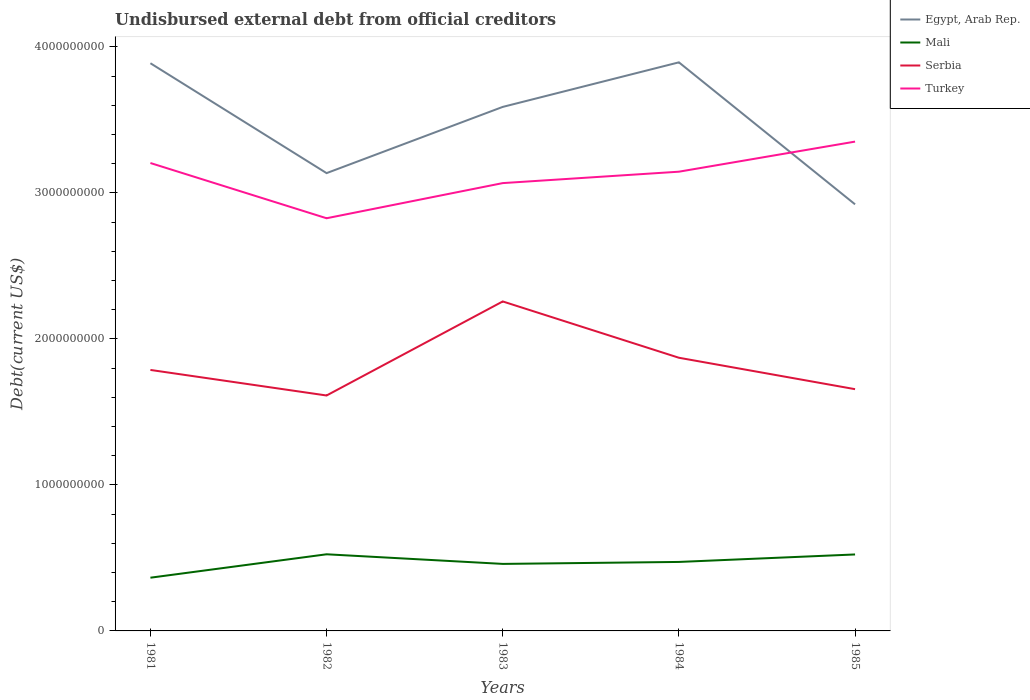How many different coloured lines are there?
Keep it short and to the point. 4. Does the line corresponding to Mali intersect with the line corresponding to Serbia?
Your answer should be very brief. No. Across all years, what is the maximum total debt in Mali?
Make the answer very short. 3.65e+08. What is the total total debt in Turkey in the graph?
Your answer should be compact. -1.47e+08. What is the difference between the highest and the second highest total debt in Turkey?
Offer a terse response. 5.25e+08. Is the total debt in Turkey strictly greater than the total debt in Serbia over the years?
Offer a very short reply. No. How many lines are there?
Offer a terse response. 4. What is the difference between two consecutive major ticks on the Y-axis?
Give a very brief answer. 1.00e+09. Are the values on the major ticks of Y-axis written in scientific E-notation?
Your answer should be compact. No. Does the graph contain any zero values?
Offer a very short reply. No. Does the graph contain grids?
Make the answer very short. No. Where does the legend appear in the graph?
Make the answer very short. Top right. How many legend labels are there?
Your answer should be very brief. 4. How are the legend labels stacked?
Give a very brief answer. Vertical. What is the title of the graph?
Your answer should be very brief. Undisbursed external debt from official creditors. Does "High income: OECD" appear as one of the legend labels in the graph?
Offer a terse response. No. What is the label or title of the X-axis?
Offer a very short reply. Years. What is the label or title of the Y-axis?
Keep it short and to the point. Debt(current US$). What is the Debt(current US$) of Egypt, Arab Rep. in 1981?
Offer a terse response. 3.89e+09. What is the Debt(current US$) in Mali in 1981?
Keep it short and to the point. 3.65e+08. What is the Debt(current US$) of Serbia in 1981?
Give a very brief answer. 1.79e+09. What is the Debt(current US$) of Turkey in 1981?
Provide a short and direct response. 3.20e+09. What is the Debt(current US$) in Egypt, Arab Rep. in 1982?
Provide a short and direct response. 3.14e+09. What is the Debt(current US$) of Mali in 1982?
Offer a very short reply. 5.25e+08. What is the Debt(current US$) of Serbia in 1982?
Make the answer very short. 1.61e+09. What is the Debt(current US$) in Turkey in 1982?
Ensure brevity in your answer.  2.83e+09. What is the Debt(current US$) in Egypt, Arab Rep. in 1983?
Offer a very short reply. 3.59e+09. What is the Debt(current US$) in Mali in 1983?
Give a very brief answer. 4.59e+08. What is the Debt(current US$) in Serbia in 1983?
Provide a short and direct response. 2.26e+09. What is the Debt(current US$) in Turkey in 1983?
Your answer should be compact. 3.07e+09. What is the Debt(current US$) in Egypt, Arab Rep. in 1984?
Provide a short and direct response. 3.89e+09. What is the Debt(current US$) in Mali in 1984?
Offer a very short reply. 4.72e+08. What is the Debt(current US$) in Serbia in 1984?
Provide a short and direct response. 1.87e+09. What is the Debt(current US$) of Turkey in 1984?
Your answer should be compact. 3.15e+09. What is the Debt(current US$) of Egypt, Arab Rep. in 1985?
Your answer should be very brief. 2.92e+09. What is the Debt(current US$) in Mali in 1985?
Provide a succinct answer. 5.24e+08. What is the Debt(current US$) in Serbia in 1985?
Make the answer very short. 1.66e+09. What is the Debt(current US$) in Turkey in 1985?
Your answer should be compact. 3.35e+09. Across all years, what is the maximum Debt(current US$) in Egypt, Arab Rep.?
Your response must be concise. 3.89e+09. Across all years, what is the maximum Debt(current US$) of Mali?
Offer a very short reply. 5.25e+08. Across all years, what is the maximum Debt(current US$) in Serbia?
Your answer should be compact. 2.26e+09. Across all years, what is the maximum Debt(current US$) in Turkey?
Give a very brief answer. 3.35e+09. Across all years, what is the minimum Debt(current US$) in Egypt, Arab Rep.?
Provide a succinct answer. 2.92e+09. Across all years, what is the minimum Debt(current US$) in Mali?
Make the answer very short. 3.65e+08. Across all years, what is the minimum Debt(current US$) of Serbia?
Ensure brevity in your answer.  1.61e+09. Across all years, what is the minimum Debt(current US$) in Turkey?
Make the answer very short. 2.83e+09. What is the total Debt(current US$) in Egypt, Arab Rep. in the graph?
Your answer should be very brief. 1.74e+1. What is the total Debt(current US$) of Mali in the graph?
Your response must be concise. 2.34e+09. What is the total Debt(current US$) of Serbia in the graph?
Your response must be concise. 9.18e+09. What is the total Debt(current US$) of Turkey in the graph?
Provide a short and direct response. 1.56e+1. What is the difference between the Debt(current US$) of Egypt, Arab Rep. in 1981 and that in 1982?
Your answer should be compact. 7.53e+08. What is the difference between the Debt(current US$) in Mali in 1981 and that in 1982?
Offer a terse response. -1.60e+08. What is the difference between the Debt(current US$) of Serbia in 1981 and that in 1982?
Keep it short and to the point. 1.75e+08. What is the difference between the Debt(current US$) in Turkey in 1981 and that in 1982?
Provide a short and direct response. 3.78e+08. What is the difference between the Debt(current US$) in Egypt, Arab Rep. in 1981 and that in 1983?
Give a very brief answer. 2.99e+08. What is the difference between the Debt(current US$) of Mali in 1981 and that in 1983?
Make the answer very short. -9.45e+07. What is the difference between the Debt(current US$) in Serbia in 1981 and that in 1983?
Keep it short and to the point. -4.69e+08. What is the difference between the Debt(current US$) of Turkey in 1981 and that in 1983?
Provide a succinct answer. 1.38e+08. What is the difference between the Debt(current US$) of Egypt, Arab Rep. in 1981 and that in 1984?
Your answer should be compact. -6.11e+06. What is the difference between the Debt(current US$) of Mali in 1981 and that in 1984?
Provide a short and direct response. -1.08e+08. What is the difference between the Debt(current US$) of Serbia in 1981 and that in 1984?
Make the answer very short. -8.35e+07. What is the difference between the Debt(current US$) in Turkey in 1981 and that in 1984?
Offer a terse response. 5.95e+07. What is the difference between the Debt(current US$) in Egypt, Arab Rep. in 1981 and that in 1985?
Your answer should be very brief. 9.66e+08. What is the difference between the Debt(current US$) of Mali in 1981 and that in 1985?
Your answer should be very brief. -1.59e+08. What is the difference between the Debt(current US$) in Serbia in 1981 and that in 1985?
Provide a succinct answer. 1.32e+08. What is the difference between the Debt(current US$) of Turkey in 1981 and that in 1985?
Provide a succinct answer. -1.47e+08. What is the difference between the Debt(current US$) of Egypt, Arab Rep. in 1982 and that in 1983?
Provide a short and direct response. -4.54e+08. What is the difference between the Debt(current US$) of Mali in 1982 and that in 1983?
Provide a short and direct response. 6.59e+07. What is the difference between the Debt(current US$) in Serbia in 1982 and that in 1983?
Your answer should be compact. -6.44e+08. What is the difference between the Debt(current US$) of Turkey in 1982 and that in 1983?
Keep it short and to the point. -2.41e+08. What is the difference between the Debt(current US$) of Egypt, Arab Rep. in 1982 and that in 1984?
Your response must be concise. -7.59e+08. What is the difference between the Debt(current US$) in Mali in 1982 and that in 1984?
Make the answer very short. 5.24e+07. What is the difference between the Debt(current US$) in Serbia in 1982 and that in 1984?
Provide a succinct answer. -2.59e+08. What is the difference between the Debt(current US$) of Turkey in 1982 and that in 1984?
Make the answer very short. -3.19e+08. What is the difference between the Debt(current US$) in Egypt, Arab Rep. in 1982 and that in 1985?
Offer a very short reply. 2.14e+08. What is the difference between the Debt(current US$) in Mali in 1982 and that in 1985?
Make the answer very short. 1.17e+06. What is the difference between the Debt(current US$) of Serbia in 1982 and that in 1985?
Ensure brevity in your answer.  -4.33e+07. What is the difference between the Debt(current US$) of Turkey in 1982 and that in 1985?
Give a very brief answer. -5.25e+08. What is the difference between the Debt(current US$) in Egypt, Arab Rep. in 1983 and that in 1984?
Your answer should be very brief. -3.05e+08. What is the difference between the Debt(current US$) of Mali in 1983 and that in 1984?
Your answer should be very brief. -1.34e+07. What is the difference between the Debt(current US$) of Serbia in 1983 and that in 1984?
Make the answer very short. 3.86e+08. What is the difference between the Debt(current US$) in Turkey in 1983 and that in 1984?
Offer a very short reply. -7.81e+07. What is the difference between the Debt(current US$) of Egypt, Arab Rep. in 1983 and that in 1985?
Offer a very short reply. 6.67e+08. What is the difference between the Debt(current US$) in Mali in 1983 and that in 1985?
Your response must be concise. -6.47e+07. What is the difference between the Debt(current US$) in Serbia in 1983 and that in 1985?
Provide a short and direct response. 6.01e+08. What is the difference between the Debt(current US$) of Turkey in 1983 and that in 1985?
Give a very brief answer. -2.84e+08. What is the difference between the Debt(current US$) of Egypt, Arab Rep. in 1984 and that in 1985?
Provide a short and direct response. 9.72e+08. What is the difference between the Debt(current US$) in Mali in 1984 and that in 1985?
Offer a very short reply. -5.13e+07. What is the difference between the Debt(current US$) of Serbia in 1984 and that in 1985?
Offer a terse response. 2.15e+08. What is the difference between the Debt(current US$) of Turkey in 1984 and that in 1985?
Make the answer very short. -2.06e+08. What is the difference between the Debt(current US$) of Egypt, Arab Rep. in 1981 and the Debt(current US$) of Mali in 1982?
Ensure brevity in your answer.  3.36e+09. What is the difference between the Debt(current US$) in Egypt, Arab Rep. in 1981 and the Debt(current US$) in Serbia in 1982?
Make the answer very short. 2.28e+09. What is the difference between the Debt(current US$) in Egypt, Arab Rep. in 1981 and the Debt(current US$) in Turkey in 1982?
Your answer should be very brief. 1.06e+09. What is the difference between the Debt(current US$) of Mali in 1981 and the Debt(current US$) of Serbia in 1982?
Your answer should be very brief. -1.25e+09. What is the difference between the Debt(current US$) of Mali in 1981 and the Debt(current US$) of Turkey in 1982?
Your answer should be very brief. -2.46e+09. What is the difference between the Debt(current US$) of Serbia in 1981 and the Debt(current US$) of Turkey in 1982?
Give a very brief answer. -1.04e+09. What is the difference between the Debt(current US$) in Egypt, Arab Rep. in 1981 and the Debt(current US$) in Mali in 1983?
Your answer should be compact. 3.43e+09. What is the difference between the Debt(current US$) of Egypt, Arab Rep. in 1981 and the Debt(current US$) of Serbia in 1983?
Offer a very short reply. 1.63e+09. What is the difference between the Debt(current US$) in Egypt, Arab Rep. in 1981 and the Debt(current US$) in Turkey in 1983?
Make the answer very short. 8.21e+08. What is the difference between the Debt(current US$) in Mali in 1981 and the Debt(current US$) in Serbia in 1983?
Provide a succinct answer. -1.89e+09. What is the difference between the Debt(current US$) of Mali in 1981 and the Debt(current US$) of Turkey in 1983?
Provide a short and direct response. -2.70e+09. What is the difference between the Debt(current US$) in Serbia in 1981 and the Debt(current US$) in Turkey in 1983?
Your answer should be very brief. -1.28e+09. What is the difference between the Debt(current US$) of Egypt, Arab Rep. in 1981 and the Debt(current US$) of Mali in 1984?
Offer a very short reply. 3.42e+09. What is the difference between the Debt(current US$) of Egypt, Arab Rep. in 1981 and the Debt(current US$) of Serbia in 1984?
Provide a succinct answer. 2.02e+09. What is the difference between the Debt(current US$) in Egypt, Arab Rep. in 1981 and the Debt(current US$) in Turkey in 1984?
Your response must be concise. 7.43e+08. What is the difference between the Debt(current US$) in Mali in 1981 and the Debt(current US$) in Serbia in 1984?
Give a very brief answer. -1.51e+09. What is the difference between the Debt(current US$) of Mali in 1981 and the Debt(current US$) of Turkey in 1984?
Provide a short and direct response. -2.78e+09. What is the difference between the Debt(current US$) of Serbia in 1981 and the Debt(current US$) of Turkey in 1984?
Provide a short and direct response. -1.36e+09. What is the difference between the Debt(current US$) in Egypt, Arab Rep. in 1981 and the Debt(current US$) in Mali in 1985?
Your answer should be very brief. 3.36e+09. What is the difference between the Debt(current US$) of Egypt, Arab Rep. in 1981 and the Debt(current US$) of Serbia in 1985?
Your response must be concise. 2.23e+09. What is the difference between the Debt(current US$) in Egypt, Arab Rep. in 1981 and the Debt(current US$) in Turkey in 1985?
Your answer should be compact. 5.37e+08. What is the difference between the Debt(current US$) of Mali in 1981 and the Debt(current US$) of Serbia in 1985?
Your answer should be very brief. -1.29e+09. What is the difference between the Debt(current US$) of Mali in 1981 and the Debt(current US$) of Turkey in 1985?
Provide a short and direct response. -2.99e+09. What is the difference between the Debt(current US$) of Serbia in 1981 and the Debt(current US$) of Turkey in 1985?
Provide a short and direct response. -1.56e+09. What is the difference between the Debt(current US$) in Egypt, Arab Rep. in 1982 and the Debt(current US$) in Mali in 1983?
Offer a very short reply. 2.68e+09. What is the difference between the Debt(current US$) of Egypt, Arab Rep. in 1982 and the Debt(current US$) of Serbia in 1983?
Ensure brevity in your answer.  8.79e+08. What is the difference between the Debt(current US$) in Egypt, Arab Rep. in 1982 and the Debt(current US$) in Turkey in 1983?
Your response must be concise. 6.83e+07. What is the difference between the Debt(current US$) of Mali in 1982 and the Debt(current US$) of Serbia in 1983?
Your answer should be very brief. -1.73e+09. What is the difference between the Debt(current US$) in Mali in 1982 and the Debt(current US$) in Turkey in 1983?
Offer a very short reply. -2.54e+09. What is the difference between the Debt(current US$) of Serbia in 1982 and the Debt(current US$) of Turkey in 1983?
Make the answer very short. -1.45e+09. What is the difference between the Debt(current US$) of Egypt, Arab Rep. in 1982 and the Debt(current US$) of Mali in 1984?
Make the answer very short. 2.66e+09. What is the difference between the Debt(current US$) in Egypt, Arab Rep. in 1982 and the Debt(current US$) in Serbia in 1984?
Make the answer very short. 1.26e+09. What is the difference between the Debt(current US$) in Egypt, Arab Rep. in 1982 and the Debt(current US$) in Turkey in 1984?
Your response must be concise. -9.78e+06. What is the difference between the Debt(current US$) of Mali in 1982 and the Debt(current US$) of Serbia in 1984?
Provide a short and direct response. -1.35e+09. What is the difference between the Debt(current US$) in Mali in 1982 and the Debt(current US$) in Turkey in 1984?
Offer a terse response. -2.62e+09. What is the difference between the Debt(current US$) in Serbia in 1982 and the Debt(current US$) in Turkey in 1984?
Offer a very short reply. -1.53e+09. What is the difference between the Debt(current US$) in Egypt, Arab Rep. in 1982 and the Debt(current US$) in Mali in 1985?
Your answer should be compact. 2.61e+09. What is the difference between the Debt(current US$) in Egypt, Arab Rep. in 1982 and the Debt(current US$) in Serbia in 1985?
Offer a very short reply. 1.48e+09. What is the difference between the Debt(current US$) in Egypt, Arab Rep. in 1982 and the Debt(current US$) in Turkey in 1985?
Give a very brief answer. -2.16e+08. What is the difference between the Debt(current US$) in Mali in 1982 and the Debt(current US$) in Serbia in 1985?
Give a very brief answer. -1.13e+09. What is the difference between the Debt(current US$) in Mali in 1982 and the Debt(current US$) in Turkey in 1985?
Your answer should be very brief. -2.83e+09. What is the difference between the Debt(current US$) in Serbia in 1982 and the Debt(current US$) in Turkey in 1985?
Keep it short and to the point. -1.74e+09. What is the difference between the Debt(current US$) of Egypt, Arab Rep. in 1983 and the Debt(current US$) of Mali in 1984?
Offer a very short reply. 3.12e+09. What is the difference between the Debt(current US$) in Egypt, Arab Rep. in 1983 and the Debt(current US$) in Serbia in 1984?
Provide a succinct answer. 1.72e+09. What is the difference between the Debt(current US$) in Egypt, Arab Rep. in 1983 and the Debt(current US$) in Turkey in 1984?
Your answer should be very brief. 4.44e+08. What is the difference between the Debt(current US$) of Mali in 1983 and the Debt(current US$) of Serbia in 1984?
Provide a short and direct response. -1.41e+09. What is the difference between the Debt(current US$) in Mali in 1983 and the Debt(current US$) in Turkey in 1984?
Give a very brief answer. -2.69e+09. What is the difference between the Debt(current US$) of Serbia in 1983 and the Debt(current US$) of Turkey in 1984?
Make the answer very short. -8.89e+08. What is the difference between the Debt(current US$) in Egypt, Arab Rep. in 1983 and the Debt(current US$) in Mali in 1985?
Offer a very short reply. 3.07e+09. What is the difference between the Debt(current US$) in Egypt, Arab Rep. in 1983 and the Debt(current US$) in Serbia in 1985?
Your answer should be very brief. 1.93e+09. What is the difference between the Debt(current US$) of Egypt, Arab Rep. in 1983 and the Debt(current US$) of Turkey in 1985?
Make the answer very short. 2.38e+08. What is the difference between the Debt(current US$) of Mali in 1983 and the Debt(current US$) of Serbia in 1985?
Your answer should be very brief. -1.20e+09. What is the difference between the Debt(current US$) in Mali in 1983 and the Debt(current US$) in Turkey in 1985?
Your answer should be compact. -2.89e+09. What is the difference between the Debt(current US$) in Serbia in 1983 and the Debt(current US$) in Turkey in 1985?
Your answer should be very brief. -1.09e+09. What is the difference between the Debt(current US$) in Egypt, Arab Rep. in 1984 and the Debt(current US$) in Mali in 1985?
Make the answer very short. 3.37e+09. What is the difference between the Debt(current US$) of Egypt, Arab Rep. in 1984 and the Debt(current US$) of Serbia in 1985?
Offer a terse response. 2.24e+09. What is the difference between the Debt(current US$) in Egypt, Arab Rep. in 1984 and the Debt(current US$) in Turkey in 1985?
Offer a very short reply. 5.43e+08. What is the difference between the Debt(current US$) of Mali in 1984 and the Debt(current US$) of Serbia in 1985?
Your response must be concise. -1.18e+09. What is the difference between the Debt(current US$) of Mali in 1984 and the Debt(current US$) of Turkey in 1985?
Your response must be concise. -2.88e+09. What is the difference between the Debt(current US$) of Serbia in 1984 and the Debt(current US$) of Turkey in 1985?
Make the answer very short. -1.48e+09. What is the average Debt(current US$) in Egypt, Arab Rep. per year?
Make the answer very short. 3.49e+09. What is the average Debt(current US$) in Mali per year?
Your response must be concise. 4.69e+08. What is the average Debt(current US$) of Serbia per year?
Provide a short and direct response. 1.84e+09. What is the average Debt(current US$) in Turkey per year?
Give a very brief answer. 3.12e+09. In the year 1981, what is the difference between the Debt(current US$) of Egypt, Arab Rep. and Debt(current US$) of Mali?
Your answer should be compact. 3.52e+09. In the year 1981, what is the difference between the Debt(current US$) of Egypt, Arab Rep. and Debt(current US$) of Serbia?
Your answer should be very brief. 2.10e+09. In the year 1981, what is the difference between the Debt(current US$) in Egypt, Arab Rep. and Debt(current US$) in Turkey?
Offer a terse response. 6.83e+08. In the year 1981, what is the difference between the Debt(current US$) of Mali and Debt(current US$) of Serbia?
Your answer should be very brief. -1.42e+09. In the year 1981, what is the difference between the Debt(current US$) in Mali and Debt(current US$) in Turkey?
Provide a short and direct response. -2.84e+09. In the year 1981, what is the difference between the Debt(current US$) in Serbia and Debt(current US$) in Turkey?
Offer a terse response. -1.42e+09. In the year 1982, what is the difference between the Debt(current US$) of Egypt, Arab Rep. and Debt(current US$) of Mali?
Give a very brief answer. 2.61e+09. In the year 1982, what is the difference between the Debt(current US$) in Egypt, Arab Rep. and Debt(current US$) in Serbia?
Offer a terse response. 1.52e+09. In the year 1982, what is the difference between the Debt(current US$) of Egypt, Arab Rep. and Debt(current US$) of Turkey?
Offer a very short reply. 3.09e+08. In the year 1982, what is the difference between the Debt(current US$) in Mali and Debt(current US$) in Serbia?
Your answer should be compact. -1.09e+09. In the year 1982, what is the difference between the Debt(current US$) in Mali and Debt(current US$) in Turkey?
Make the answer very short. -2.30e+09. In the year 1982, what is the difference between the Debt(current US$) in Serbia and Debt(current US$) in Turkey?
Your answer should be compact. -1.21e+09. In the year 1983, what is the difference between the Debt(current US$) in Egypt, Arab Rep. and Debt(current US$) in Mali?
Ensure brevity in your answer.  3.13e+09. In the year 1983, what is the difference between the Debt(current US$) in Egypt, Arab Rep. and Debt(current US$) in Serbia?
Your response must be concise. 1.33e+09. In the year 1983, what is the difference between the Debt(current US$) in Egypt, Arab Rep. and Debt(current US$) in Turkey?
Keep it short and to the point. 5.22e+08. In the year 1983, what is the difference between the Debt(current US$) in Mali and Debt(current US$) in Serbia?
Your response must be concise. -1.80e+09. In the year 1983, what is the difference between the Debt(current US$) of Mali and Debt(current US$) of Turkey?
Provide a short and direct response. -2.61e+09. In the year 1983, what is the difference between the Debt(current US$) of Serbia and Debt(current US$) of Turkey?
Offer a very short reply. -8.10e+08. In the year 1984, what is the difference between the Debt(current US$) in Egypt, Arab Rep. and Debt(current US$) in Mali?
Keep it short and to the point. 3.42e+09. In the year 1984, what is the difference between the Debt(current US$) of Egypt, Arab Rep. and Debt(current US$) of Serbia?
Your answer should be very brief. 2.02e+09. In the year 1984, what is the difference between the Debt(current US$) of Egypt, Arab Rep. and Debt(current US$) of Turkey?
Keep it short and to the point. 7.49e+08. In the year 1984, what is the difference between the Debt(current US$) in Mali and Debt(current US$) in Serbia?
Make the answer very short. -1.40e+09. In the year 1984, what is the difference between the Debt(current US$) in Mali and Debt(current US$) in Turkey?
Keep it short and to the point. -2.67e+09. In the year 1984, what is the difference between the Debt(current US$) in Serbia and Debt(current US$) in Turkey?
Your response must be concise. -1.27e+09. In the year 1985, what is the difference between the Debt(current US$) of Egypt, Arab Rep. and Debt(current US$) of Mali?
Offer a terse response. 2.40e+09. In the year 1985, what is the difference between the Debt(current US$) in Egypt, Arab Rep. and Debt(current US$) in Serbia?
Offer a terse response. 1.27e+09. In the year 1985, what is the difference between the Debt(current US$) in Egypt, Arab Rep. and Debt(current US$) in Turkey?
Give a very brief answer. -4.30e+08. In the year 1985, what is the difference between the Debt(current US$) of Mali and Debt(current US$) of Serbia?
Your answer should be compact. -1.13e+09. In the year 1985, what is the difference between the Debt(current US$) in Mali and Debt(current US$) in Turkey?
Ensure brevity in your answer.  -2.83e+09. In the year 1985, what is the difference between the Debt(current US$) of Serbia and Debt(current US$) of Turkey?
Make the answer very short. -1.70e+09. What is the ratio of the Debt(current US$) in Egypt, Arab Rep. in 1981 to that in 1982?
Offer a very short reply. 1.24. What is the ratio of the Debt(current US$) of Mali in 1981 to that in 1982?
Offer a terse response. 0.69. What is the ratio of the Debt(current US$) of Serbia in 1981 to that in 1982?
Provide a succinct answer. 1.11. What is the ratio of the Debt(current US$) of Turkey in 1981 to that in 1982?
Your response must be concise. 1.13. What is the ratio of the Debt(current US$) in Egypt, Arab Rep. in 1981 to that in 1983?
Offer a very short reply. 1.08. What is the ratio of the Debt(current US$) of Mali in 1981 to that in 1983?
Provide a succinct answer. 0.79. What is the ratio of the Debt(current US$) of Serbia in 1981 to that in 1983?
Your answer should be very brief. 0.79. What is the ratio of the Debt(current US$) of Turkey in 1981 to that in 1983?
Make the answer very short. 1.04. What is the ratio of the Debt(current US$) of Egypt, Arab Rep. in 1981 to that in 1984?
Your answer should be compact. 1. What is the ratio of the Debt(current US$) of Mali in 1981 to that in 1984?
Your answer should be very brief. 0.77. What is the ratio of the Debt(current US$) in Serbia in 1981 to that in 1984?
Make the answer very short. 0.96. What is the ratio of the Debt(current US$) of Turkey in 1981 to that in 1984?
Ensure brevity in your answer.  1.02. What is the ratio of the Debt(current US$) of Egypt, Arab Rep. in 1981 to that in 1985?
Offer a terse response. 1.33. What is the ratio of the Debt(current US$) in Mali in 1981 to that in 1985?
Ensure brevity in your answer.  0.7. What is the ratio of the Debt(current US$) of Serbia in 1981 to that in 1985?
Your answer should be compact. 1.08. What is the ratio of the Debt(current US$) of Turkey in 1981 to that in 1985?
Your response must be concise. 0.96. What is the ratio of the Debt(current US$) in Egypt, Arab Rep. in 1982 to that in 1983?
Offer a terse response. 0.87. What is the ratio of the Debt(current US$) in Mali in 1982 to that in 1983?
Keep it short and to the point. 1.14. What is the ratio of the Debt(current US$) of Serbia in 1982 to that in 1983?
Make the answer very short. 0.71. What is the ratio of the Debt(current US$) of Turkey in 1982 to that in 1983?
Provide a succinct answer. 0.92. What is the ratio of the Debt(current US$) of Egypt, Arab Rep. in 1982 to that in 1984?
Keep it short and to the point. 0.81. What is the ratio of the Debt(current US$) of Mali in 1982 to that in 1984?
Make the answer very short. 1.11. What is the ratio of the Debt(current US$) in Serbia in 1982 to that in 1984?
Give a very brief answer. 0.86. What is the ratio of the Debt(current US$) of Turkey in 1982 to that in 1984?
Your answer should be compact. 0.9. What is the ratio of the Debt(current US$) in Egypt, Arab Rep. in 1982 to that in 1985?
Give a very brief answer. 1.07. What is the ratio of the Debt(current US$) of Serbia in 1982 to that in 1985?
Your answer should be very brief. 0.97. What is the ratio of the Debt(current US$) of Turkey in 1982 to that in 1985?
Your answer should be very brief. 0.84. What is the ratio of the Debt(current US$) of Egypt, Arab Rep. in 1983 to that in 1984?
Offer a very short reply. 0.92. What is the ratio of the Debt(current US$) of Mali in 1983 to that in 1984?
Your response must be concise. 0.97. What is the ratio of the Debt(current US$) in Serbia in 1983 to that in 1984?
Make the answer very short. 1.21. What is the ratio of the Debt(current US$) in Turkey in 1983 to that in 1984?
Ensure brevity in your answer.  0.98. What is the ratio of the Debt(current US$) of Egypt, Arab Rep. in 1983 to that in 1985?
Keep it short and to the point. 1.23. What is the ratio of the Debt(current US$) in Mali in 1983 to that in 1985?
Provide a short and direct response. 0.88. What is the ratio of the Debt(current US$) of Serbia in 1983 to that in 1985?
Provide a succinct answer. 1.36. What is the ratio of the Debt(current US$) of Turkey in 1983 to that in 1985?
Ensure brevity in your answer.  0.92. What is the ratio of the Debt(current US$) in Egypt, Arab Rep. in 1984 to that in 1985?
Provide a succinct answer. 1.33. What is the ratio of the Debt(current US$) in Mali in 1984 to that in 1985?
Make the answer very short. 0.9. What is the ratio of the Debt(current US$) of Serbia in 1984 to that in 1985?
Offer a terse response. 1.13. What is the ratio of the Debt(current US$) of Turkey in 1984 to that in 1985?
Your response must be concise. 0.94. What is the difference between the highest and the second highest Debt(current US$) of Egypt, Arab Rep.?
Keep it short and to the point. 6.11e+06. What is the difference between the highest and the second highest Debt(current US$) in Mali?
Your response must be concise. 1.17e+06. What is the difference between the highest and the second highest Debt(current US$) in Serbia?
Provide a short and direct response. 3.86e+08. What is the difference between the highest and the second highest Debt(current US$) in Turkey?
Offer a very short reply. 1.47e+08. What is the difference between the highest and the lowest Debt(current US$) in Egypt, Arab Rep.?
Ensure brevity in your answer.  9.72e+08. What is the difference between the highest and the lowest Debt(current US$) of Mali?
Your answer should be very brief. 1.60e+08. What is the difference between the highest and the lowest Debt(current US$) of Serbia?
Your response must be concise. 6.44e+08. What is the difference between the highest and the lowest Debt(current US$) in Turkey?
Offer a very short reply. 5.25e+08. 